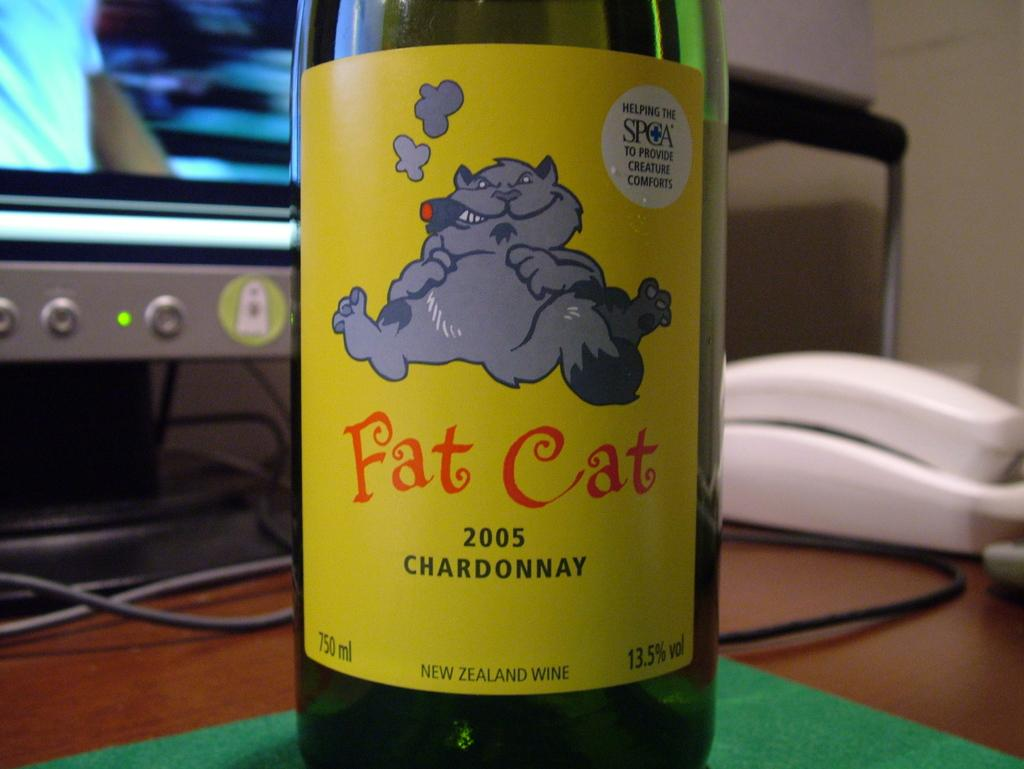<image>
Render a clear and concise summary of the photo. A bottle of Fat Cat 2005 Chardonnay sits on a desk. 